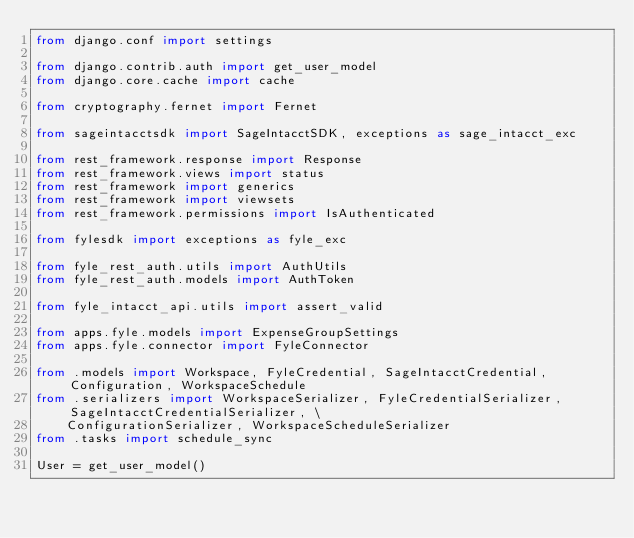<code> <loc_0><loc_0><loc_500><loc_500><_Python_>from django.conf import settings

from django.contrib.auth import get_user_model
from django.core.cache import cache

from cryptography.fernet import Fernet

from sageintacctsdk import SageIntacctSDK, exceptions as sage_intacct_exc

from rest_framework.response import Response
from rest_framework.views import status
from rest_framework import generics
from rest_framework import viewsets
from rest_framework.permissions import IsAuthenticated

from fylesdk import exceptions as fyle_exc

from fyle_rest_auth.utils import AuthUtils
from fyle_rest_auth.models import AuthToken

from fyle_intacct_api.utils import assert_valid

from apps.fyle.models import ExpenseGroupSettings
from apps.fyle.connector import FyleConnector

from .models import Workspace, FyleCredential, SageIntacctCredential, Configuration, WorkspaceSchedule
from .serializers import WorkspaceSerializer, FyleCredentialSerializer, SageIntacctCredentialSerializer, \
    ConfigurationSerializer, WorkspaceScheduleSerializer
from .tasks import schedule_sync

User = get_user_model()</code> 